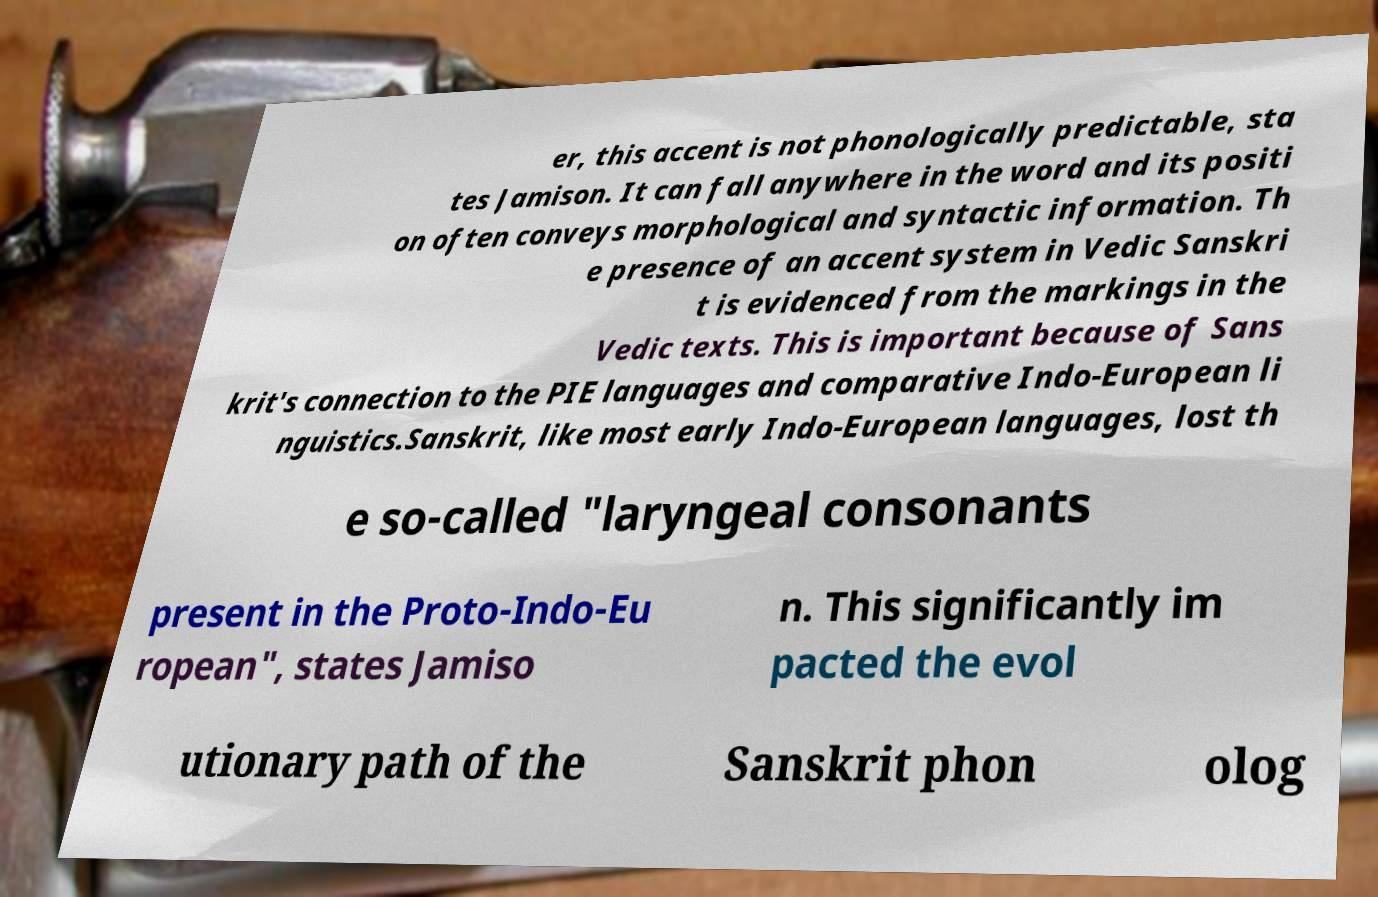What messages or text are displayed in this image? I need them in a readable, typed format. er, this accent is not phonologically predictable, sta tes Jamison. It can fall anywhere in the word and its positi on often conveys morphological and syntactic information. Th e presence of an accent system in Vedic Sanskri t is evidenced from the markings in the Vedic texts. This is important because of Sans krit's connection to the PIE languages and comparative Indo-European li nguistics.Sanskrit, like most early Indo-European languages, lost th e so-called "laryngeal consonants present in the Proto-Indo-Eu ropean", states Jamiso n. This significantly im pacted the evol utionary path of the Sanskrit phon olog 